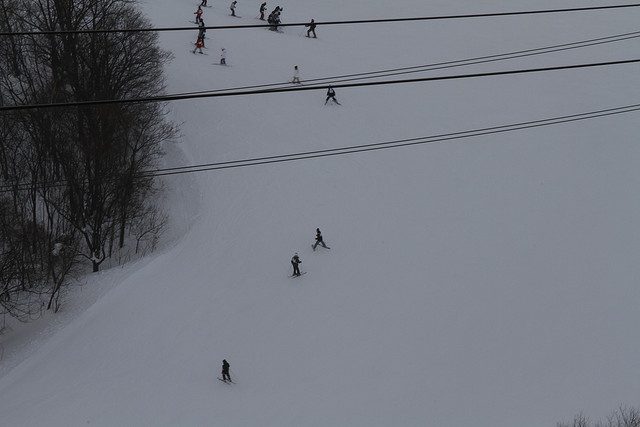Describe the objects in this image and their specific colors. I can see people in black and gray tones, people in black and gray tones, people in black and gray tones, people in black and gray tones, and people in black and gray tones in this image. 